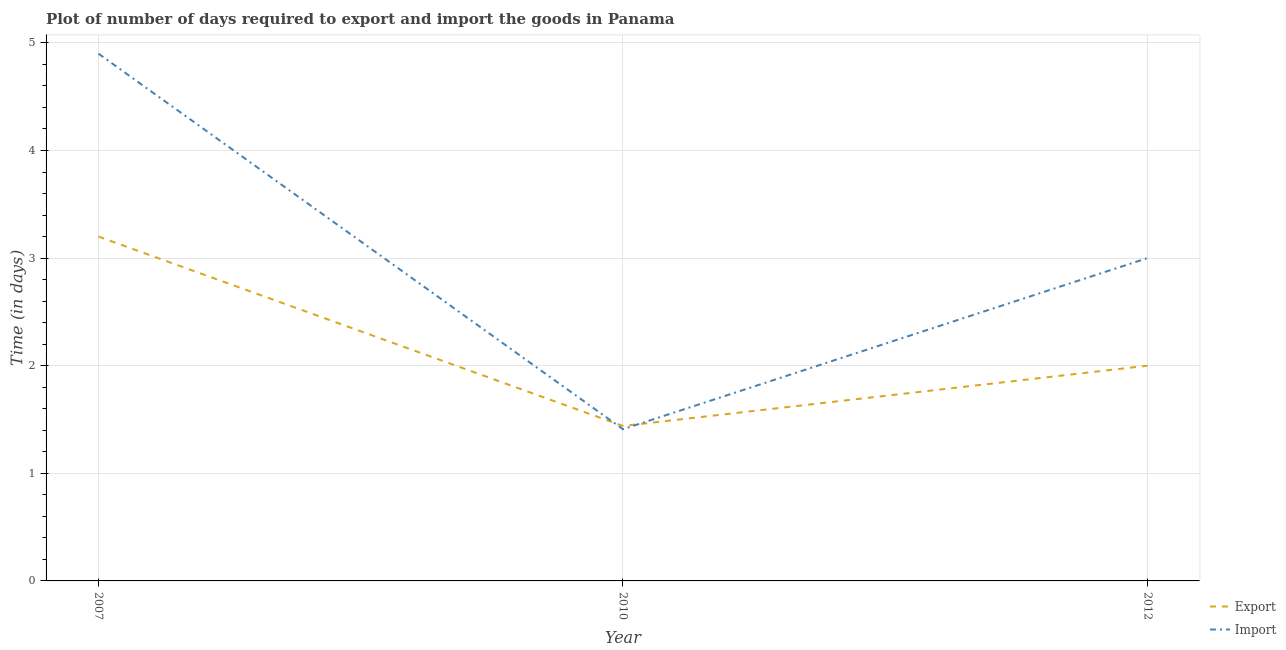Does the line corresponding to time required to import intersect with the line corresponding to time required to export?
Make the answer very short. Yes. Is the number of lines equal to the number of legend labels?
Your answer should be very brief. Yes. What is the time required to import in 2010?
Make the answer very short. 1.41. Across all years, what is the maximum time required to export?
Provide a short and direct response. 3.2. Across all years, what is the minimum time required to import?
Your answer should be very brief. 1.41. In which year was the time required to import maximum?
Your answer should be compact. 2007. In which year was the time required to export minimum?
Your answer should be very brief. 2010. What is the total time required to import in the graph?
Ensure brevity in your answer.  9.31. What is the difference between the time required to export in 2010 and that in 2012?
Your response must be concise. -0.56. What is the difference between the time required to export in 2012 and the time required to import in 2010?
Your response must be concise. 0.59. What is the average time required to import per year?
Ensure brevity in your answer.  3.1. In how many years, is the time required to import greater than 1.6 days?
Your answer should be compact. 2. What is the ratio of the time required to import in 2007 to that in 2010?
Ensure brevity in your answer.  3.48. Is the time required to export in 2007 less than that in 2012?
Ensure brevity in your answer.  No. Is the difference between the time required to export in 2010 and 2012 greater than the difference between the time required to import in 2010 and 2012?
Provide a succinct answer. Yes. What is the difference between the highest and the second highest time required to import?
Provide a succinct answer. 1.9. What is the difference between the highest and the lowest time required to export?
Your response must be concise. 1.76. In how many years, is the time required to import greater than the average time required to import taken over all years?
Your answer should be compact. 1. Is the time required to export strictly greater than the time required to import over the years?
Ensure brevity in your answer.  No. How many lines are there?
Provide a succinct answer. 2. How many years are there in the graph?
Provide a short and direct response. 3. Are the values on the major ticks of Y-axis written in scientific E-notation?
Make the answer very short. No. Does the graph contain any zero values?
Provide a succinct answer. No. Where does the legend appear in the graph?
Make the answer very short. Bottom right. How many legend labels are there?
Provide a short and direct response. 2. What is the title of the graph?
Provide a short and direct response. Plot of number of days required to export and import the goods in Panama. Does "Fertility rate" appear as one of the legend labels in the graph?
Keep it short and to the point. No. What is the label or title of the Y-axis?
Offer a terse response. Time (in days). What is the Time (in days) in Export in 2007?
Offer a terse response. 3.2. What is the Time (in days) of Export in 2010?
Provide a succinct answer. 1.44. What is the Time (in days) in Import in 2010?
Make the answer very short. 1.41. Across all years, what is the maximum Time (in days) in Export?
Your answer should be very brief. 3.2. Across all years, what is the maximum Time (in days) of Import?
Keep it short and to the point. 4.9. Across all years, what is the minimum Time (in days) of Export?
Provide a short and direct response. 1.44. Across all years, what is the minimum Time (in days) in Import?
Make the answer very short. 1.41. What is the total Time (in days) in Export in the graph?
Ensure brevity in your answer.  6.64. What is the total Time (in days) in Import in the graph?
Ensure brevity in your answer.  9.31. What is the difference between the Time (in days) in Export in 2007 and that in 2010?
Offer a very short reply. 1.76. What is the difference between the Time (in days) of Import in 2007 and that in 2010?
Your answer should be very brief. 3.49. What is the difference between the Time (in days) of Export in 2010 and that in 2012?
Give a very brief answer. -0.56. What is the difference between the Time (in days) in Import in 2010 and that in 2012?
Make the answer very short. -1.59. What is the difference between the Time (in days) in Export in 2007 and the Time (in days) in Import in 2010?
Offer a terse response. 1.79. What is the difference between the Time (in days) of Export in 2010 and the Time (in days) of Import in 2012?
Give a very brief answer. -1.56. What is the average Time (in days) of Export per year?
Your response must be concise. 2.21. What is the average Time (in days) of Import per year?
Your answer should be very brief. 3.1. In the year 2010, what is the difference between the Time (in days) in Export and Time (in days) in Import?
Provide a short and direct response. 0.03. What is the ratio of the Time (in days) in Export in 2007 to that in 2010?
Offer a terse response. 2.22. What is the ratio of the Time (in days) in Import in 2007 to that in 2010?
Provide a succinct answer. 3.48. What is the ratio of the Time (in days) of Import in 2007 to that in 2012?
Offer a terse response. 1.63. What is the ratio of the Time (in days) in Export in 2010 to that in 2012?
Your answer should be very brief. 0.72. What is the ratio of the Time (in days) of Import in 2010 to that in 2012?
Make the answer very short. 0.47. What is the difference between the highest and the second highest Time (in days) of Export?
Offer a terse response. 1.2. What is the difference between the highest and the lowest Time (in days) in Export?
Provide a succinct answer. 1.76. What is the difference between the highest and the lowest Time (in days) in Import?
Your answer should be compact. 3.49. 